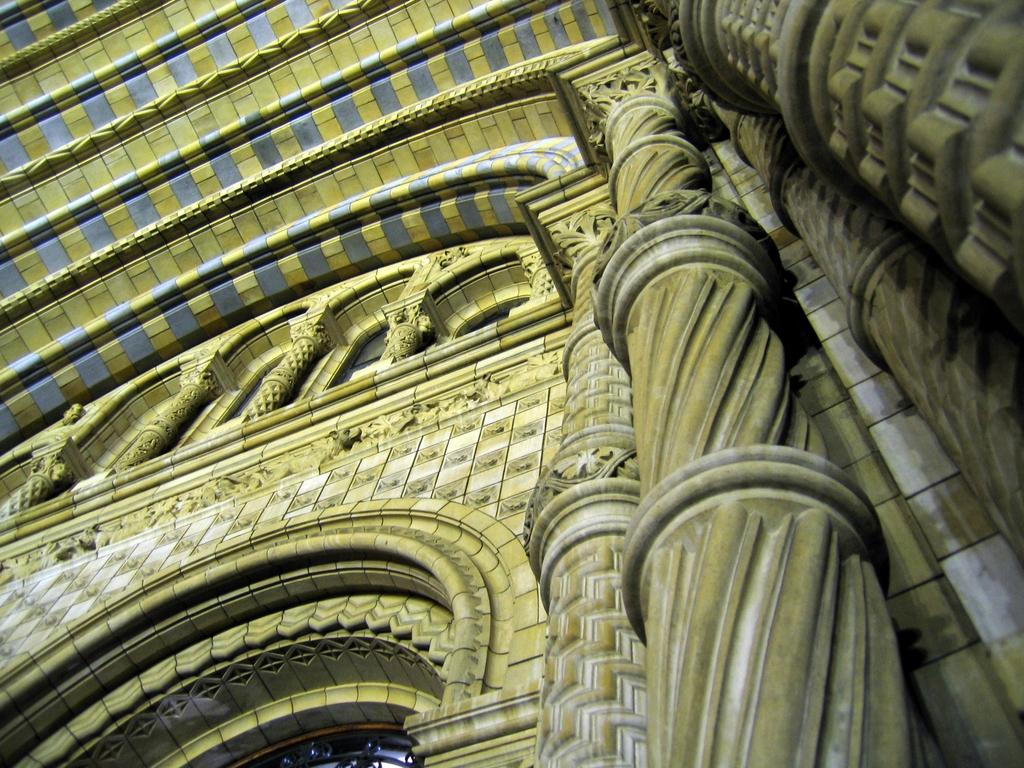What type of structure is depicted in the image? There is a wall and a roof in the image, which suggests a building or house. Can you describe the structure's features? The image shows a wall and a roof, but no other specific details are provided. How many boats are visible in the image? There are no boats present in the image; it only features a wall and a roof. What type of flower can be seen growing near the wall in the image? There is no flower present in the image; it only features a wall and a roof. 